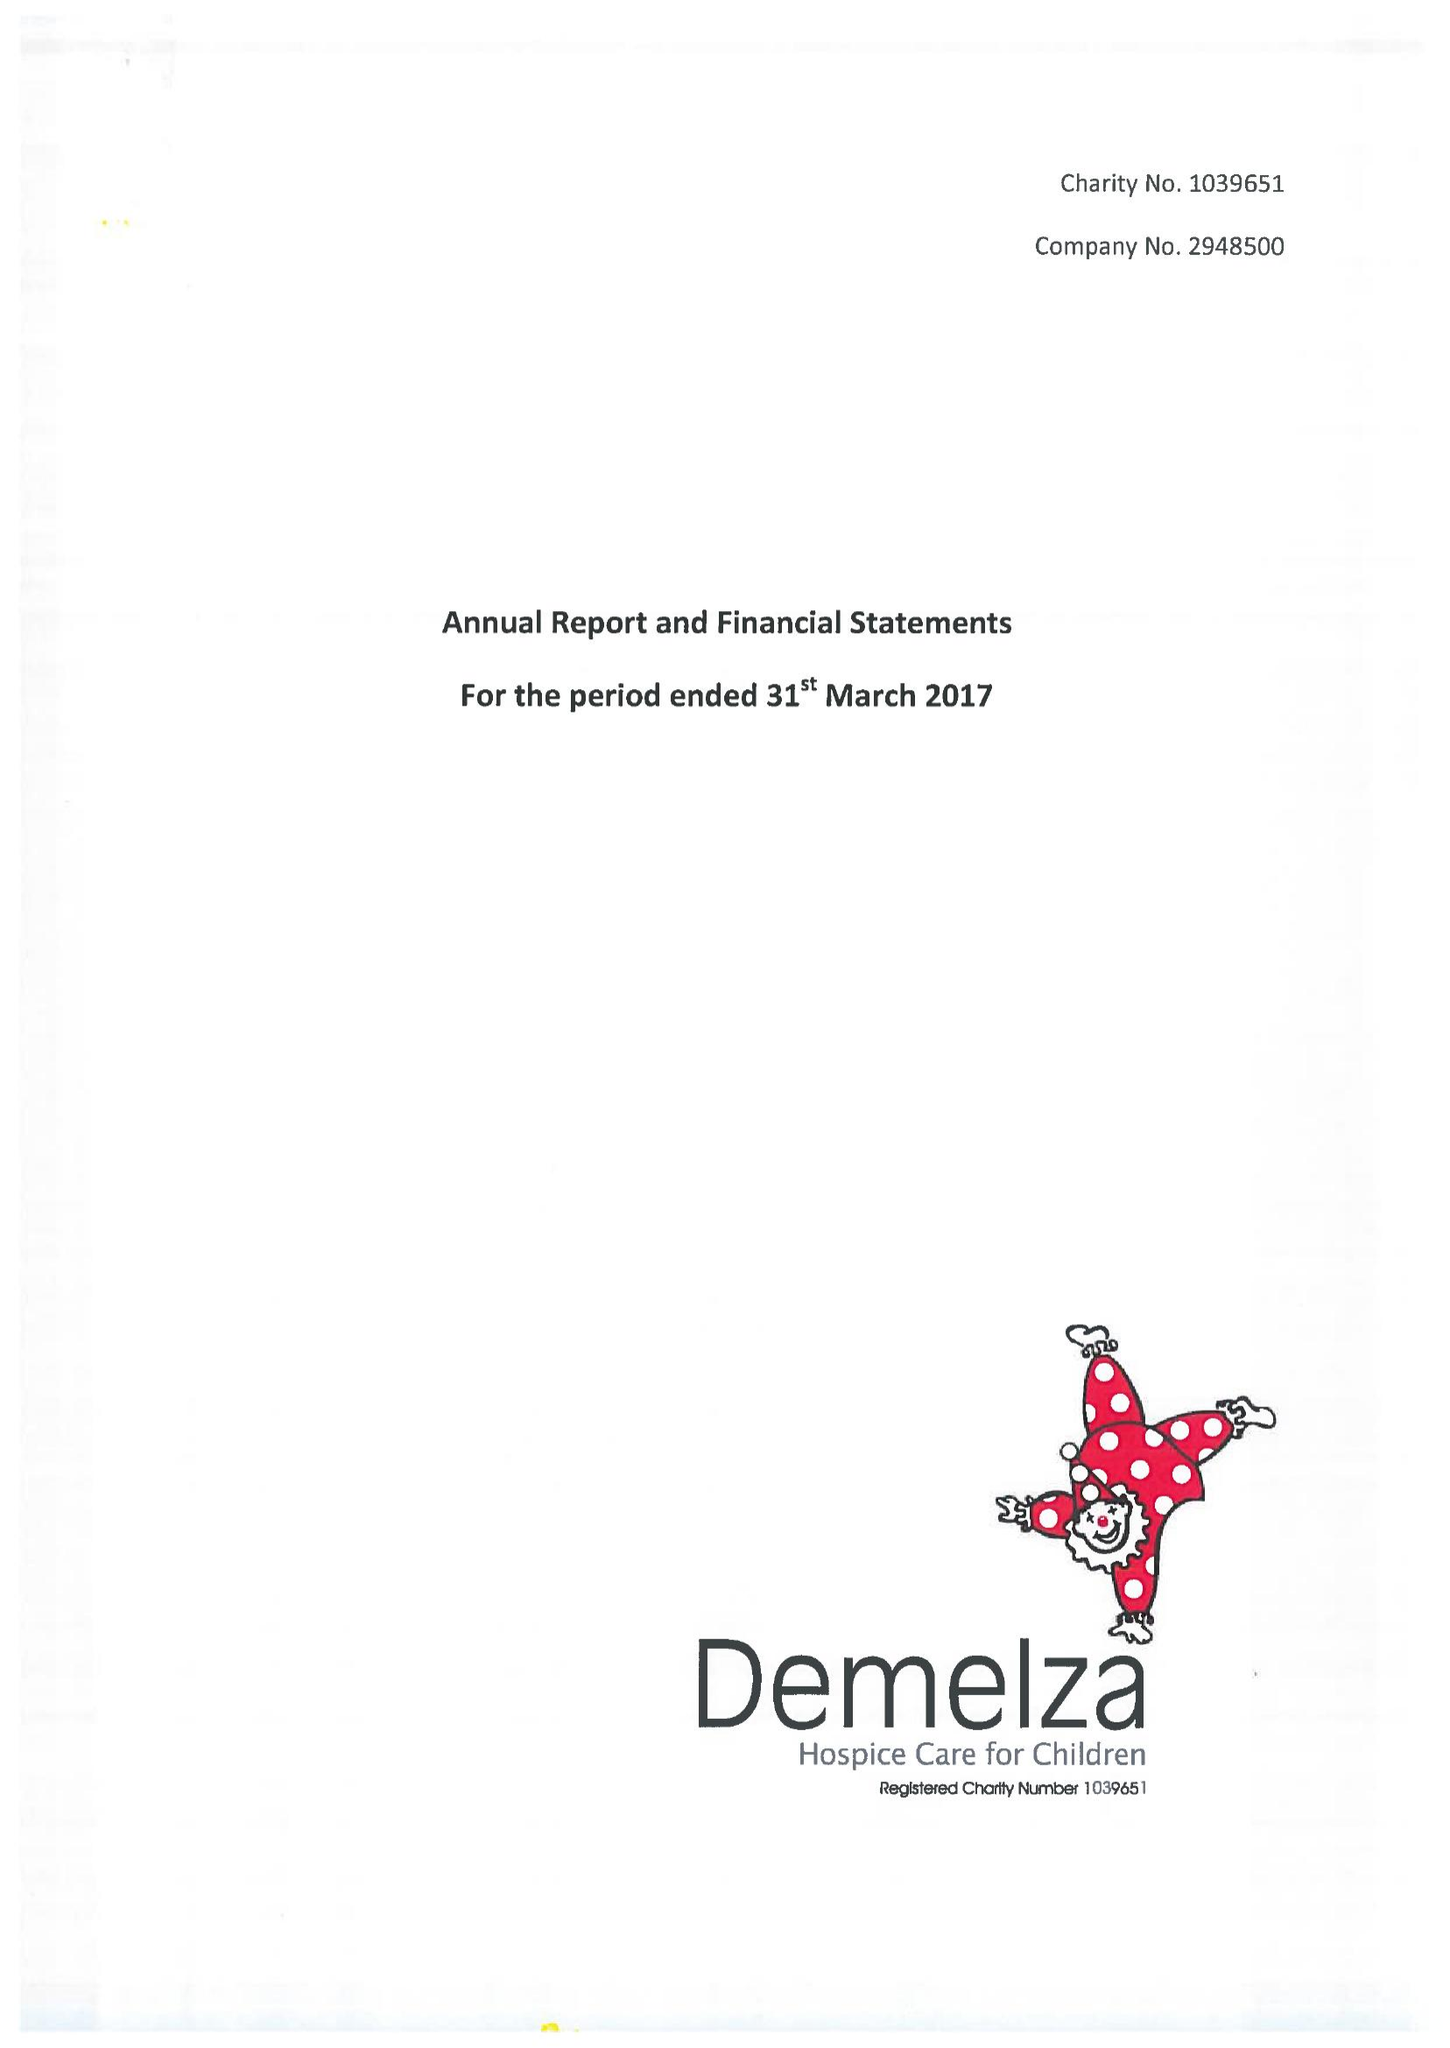What is the value for the charity_name?
Answer the question using a single word or phrase. Demelza House Childrens Hospice Ltd. 